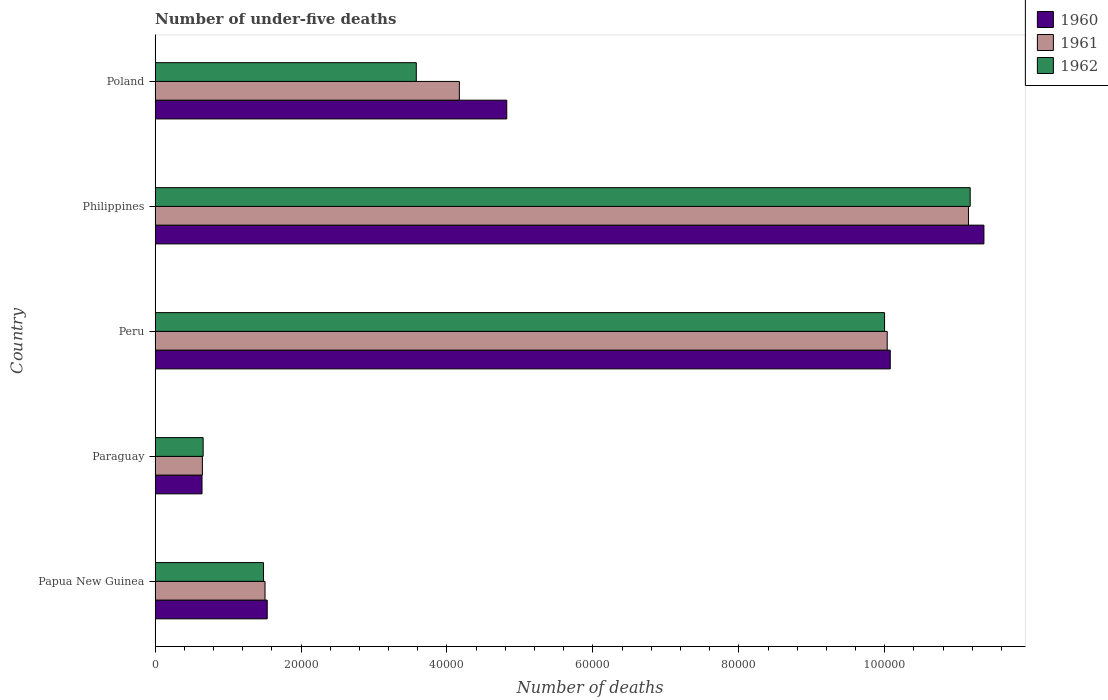How many different coloured bars are there?
Offer a very short reply. 3. How many groups of bars are there?
Your answer should be compact. 5. Are the number of bars per tick equal to the number of legend labels?
Keep it short and to the point. Yes. Are the number of bars on each tick of the Y-axis equal?
Provide a short and direct response. Yes. How many bars are there on the 5th tick from the bottom?
Make the answer very short. 3. What is the label of the 1st group of bars from the top?
Your answer should be compact. Poland. In how many cases, is the number of bars for a given country not equal to the number of legend labels?
Your answer should be very brief. 0. What is the number of under-five deaths in 1961 in Philippines?
Offer a terse response. 1.11e+05. Across all countries, what is the maximum number of under-five deaths in 1960?
Offer a very short reply. 1.14e+05. Across all countries, what is the minimum number of under-five deaths in 1960?
Your response must be concise. 6434. In which country was the number of under-five deaths in 1960 maximum?
Offer a terse response. Philippines. In which country was the number of under-five deaths in 1960 minimum?
Provide a succinct answer. Paraguay. What is the total number of under-five deaths in 1962 in the graph?
Ensure brevity in your answer.  2.69e+05. What is the difference between the number of under-five deaths in 1961 in Paraguay and that in Peru?
Make the answer very short. -9.38e+04. What is the difference between the number of under-five deaths in 1960 in Peru and the number of under-five deaths in 1962 in Poland?
Keep it short and to the point. 6.50e+04. What is the average number of under-five deaths in 1962 per country?
Offer a very short reply. 5.38e+04. What is the difference between the number of under-five deaths in 1961 and number of under-five deaths in 1962 in Peru?
Offer a very short reply. 362. What is the ratio of the number of under-five deaths in 1961 in Paraguay to that in Peru?
Provide a succinct answer. 0.06. Is the difference between the number of under-five deaths in 1961 in Paraguay and Philippines greater than the difference between the number of under-five deaths in 1962 in Paraguay and Philippines?
Offer a terse response. Yes. What is the difference between the highest and the second highest number of under-five deaths in 1962?
Your response must be concise. 1.17e+04. What is the difference between the highest and the lowest number of under-five deaths in 1961?
Make the answer very short. 1.05e+05. In how many countries, is the number of under-five deaths in 1961 greater than the average number of under-five deaths in 1961 taken over all countries?
Offer a very short reply. 2. What does the 2nd bar from the top in Philippines represents?
Your answer should be compact. 1961. How many countries are there in the graph?
Offer a very short reply. 5. What is the difference between two consecutive major ticks on the X-axis?
Keep it short and to the point. 2.00e+04. How many legend labels are there?
Provide a succinct answer. 3. How are the legend labels stacked?
Offer a terse response. Vertical. What is the title of the graph?
Provide a succinct answer. Number of under-five deaths. What is the label or title of the X-axis?
Make the answer very short. Number of deaths. What is the Number of deaths of 1960 in Papua New Guinea?
Offer a very short reply. 1.54e+04. What is the Number of deaths in 1961 in Papua New Guinea?
Provide a short and direct response. 1.51e+04. What is the Number of deaths in 1962 in Papua New Guinea?
Provide a succinct answer. 1.49e+04. What is the Number of deaths in 1960 in Paraguay?
Provide a succinct answer. 6434. What is the Number of deaths in 1961 in Paraguay?
Offer a terse response. 6486. What is the Number of deaths of 1962 in Paraguay?
Your answer should be very brief. 6590. What is the Number of deaths of 1960 in Peru?
Offer a terse response. 1.01e+05. What is the Number of deaths in 1961 in Peru?
Your answer should be very brief. 1.00e+05. What is the Number of deaths of 1962 in Peru?
Your answer should be very brief. 1.00e+05. What is the Number of deaths of 1960 in Philippines?
Your response must be concise. 1.14e+05. What is the Number of deaths in 1961 in Philippines?
Provide a short and direct response. 1.11e+05. What is the Number of deaths of 1962 in Philippines?
Ensure brevity in your answer.  1.12e+05. What is the Number of deaths of 1960 in Poland?
Your answer should be compact. 4.82e+04. What is the Number of deaths in 1961 in Poland?
Provide a short and direct response. 4.17e+04. What is the Number of deaths of 1962 in Poland?
Provide a succinct answer. 3.58e+04. Across all countries, what is the maximum Number of deaths in 1960?
Ensure brevity in your answer.  1.14e+05. Across all countries, what is the maximum Number of deaths in 1961?
Offer a terse response. 1.11e+05. Across all countries, what is the maximum Number of deaths of 1962?
Give a very brief answer. 1.12e+05. Across all countries, what is the minimum Number of deaths of 1960?
Your answer should be very brief. 6434. Across all countries, what is the minimum Number of deaths in 1961?
Your answer should be compact. 6486. Across all countries, what is the minimum Number of deaths of 1962?
Make the answer very short. 6590. What is the total Number of deaths in 1960 in the graph?
Offer a terse response. 2.84e+05. What is the total Number of deaths of 1961 in the graph?
Give a very brief answer. 2.75e+05. What is the total Number of deaths in 1962 in the graph?
Your answer should be compact. 2.69e+05. What is the difference between the Number of deaths in 1960 in Papua New Guinea and that in Paraguay?
Give a very brief answer. 8936. What is the difference between the Number of deaths in 1961 in Papua New Guinea and that in Paraguay?
Make the answer very short. 8582. What is the difference between the Number of deaths of 1962 in Papua New Guinea and that in Paraguay?
Keep it short and to the point. 8276. What is the difference between the Number of deaths in 1960 in Papua New Guinea and that in Peru?
Offer a terse response. -8.54e+04. What is the difference between the Number of deaths in 1961 in Papua New Guinea and that in Peru?
Your response must be concise. -8.53e+04. What is the difference between the Number of deaths of 1962 in Papua New Guinea and that in Peru?
Your answer should be very brief. -8.51e+04. What is the difference between the Number of deaths in 1960 in Papua New Guinea and that in Philippines?
Offer a very short reply. -9.82e+04. What is the difference between the Number of deaths of 1961 in Papua New Guinea and that in Philippines?
Provide a short and direct response. -9.64e+04. What is the difference between the Number of deaths of 1962 in Papua New Guinea and that in Philippines?
Your answer should be compact. -9.68e+04. What is the difference between the Number of deaths in 1960 in Papua New Guinea and that in Poland?
Give a very brief answer. -3.28e+04. What is the difference between the Number of deaths in 1961 in Papua New Guinea and that in Poland?
Make the answer very short. -2.66e+04. What is the difference between the Number of deaths of 1962 in Papua New Guinea and that in Poland?
Offer a terse response. -2.09e+04. What is the difference between the Number of deaths in 1960 in Paraguay and that in Peru?
Make the answer very short. -9.43e+04. What is the difference between the Number of deaths in 1961 in Paraguay and that in Peru?
Your response must be concise. -9.38e+04. What is the difference between the Number of deaths in 1962 in Paraguay and that in Peru?
Provide a short and direct response. -9.34e+04. What is the difference between the Number of deaths of 1960 in Paraguay and that in Philippines?
Your answer should be very brief. -1.07e+05. What is the difference between the Number of deaths in 1961 in Paraguay and that in Philippines?
Give a very brief answer. -1.05e+05. What is the difference between the Number of deaths of 1962 in Paraguay and that in Philippines?
Offer a very short reply. -1.05e+05. What is the difference between the Number of deaths in 1960 in Paraguay and that in Poland?
Your answer should be very brief. -4.18e+04. What is the difference between the Number of deaths in 1961 in Paraguay and that in Poland?
Give a very brief answer. -3.52e+04. What is the difference between the Number of deaths of 1962 in Paraguay and that in Poland?
Your response must be concise. -2.92e+04. What is the difference between the Number of deaths of 1960 in Peru and that in Philippines?
Your answer should be very brief. -1.28e+04. What is the difference between the Number of deaths of 1961 in Peru and that in Philippines?
Your response must be concise. -1.11e+04. What is the difference between the Number of deaths in 1962 in Peru and that in Philippines?
Ensure brevity in your answer.  -1.17e+04. What is the difference between the Number of deaths in 1960 in Peru and that in Poland?
Make the answer very short. 5.26e+04. What is the difference between the Number of deaths in 1961 in Peru and that in Poland?
Ensure brevity in your answer.  5.86e+04. What is the difference between the Number of deaths in 1962 in Peru and that in Poland?
Your answer should be compact. 6.42e+04. What is the difference between the Number of deaths in 1960 in Philippines and that in Poland?
Provide a short and direct response. 6.54e+04. What is the difference between the Number of deaths of 1961 in Philippines and that in Poland?
Offer a very short reply. 6.98e+04. What is the difference between the Number of deaths of 1962 in Philippines and that in Poland?
Provide a succinct answer. 7.59e+04. What is the difference between the Number of deaths in 1960 in Papua New Guinea and the Number of deaths in 1961 in Paraguay?
Your response must be concise. 8884. What is the difference between the Number of deaths of 1960 in Papua New Guinea and the Number of deaths of 1962 in Paraguay?
Provide a succinct answer. 8780. What is the difference between the Number of deaths in 1961 in Papua New Guinea and the Number of deaths in 1962 in Paraguay?
Ensure brevity in your answer.  8478. What is the difference between the Number of deaths in 1960 in Papua New Guinea and the Number of deaths in 1961 in Peru?
Offer a terse response. -8.50e+04. What is the difference between the Number of deaths in 1960 in Papua New Guinea and the Number of deaths in 1962 in Peru?
Offer a terse response. -8.46e+04. What is the difference between the Number of deaths in 1961 in Papua New Guinea and the Number of deaths in 1962 in Peru?
Make the answer very short. -8.49e+04. What is the difference between the Number of deaths of 1960 in Papua New Guinea and the Number of deaths of 1961 in Philippines?
Offer a terse response. -9.61e+04. What is the difference between the Number of deaths of 1960 in Papua New Guinea and the Number of deaths of 1962 in Philippines?
Offer a terse response. -9.63e+04. What is the difference between the Number of deaths in 1961 in Papua New Guinea and the Number of deaths in 1962 in Philippines?
Offer a terse response. -9.66e+04. What is the difference between the Number of deaths of 1960 in Papua New Guinea and the Number of deaths of 1961 in Poland?
Ensure brevity in your answer.  -2.63e+04. What is the difference between the Number of deaths in 1960 in Papua New Guinea and the Number of deaths in 1962 in Poland?
Provide a succinct answer. -2.04e+04. What is the difference between the Number of deaths of 1961 in Papua New Guinea and the Number of deaths of 1962 in Poland?
Offer a very short reply. -2.07e+04. What is the difference between the Number of deaths of 1960 in Paraguay and the Number of deaths of 1961 in Peru?
Provide a succinct answer. -9.39e+04. What is the difference between the Number of deaths in 1960 in Paraguay and the Number of deaths in 1962 in Peru?
Your answer should be compact. -9.35e+04. What is the difference between the Number of deaths in 1961 in Paraguay and the Number of deaths in 1962 in Peru?
Offer a terse response. -9.35e+04. What is the difference between the Number of deaths in 1960 in Paraguay and the Number of deaths in 1961 in Philippines?
Your answer should be very brief. -1.05e+05. What is the difference between the Number of deaths of 1960 in Paraguay and the Number of deaths of 1962 in Philippines?
Ensure brevity in your answer.  -1.05e+05. What is the difference between the Number of deaths of 1961 in Paraguay and the Number of deaths of 1962 in Philippines?
Your response must be concise. -1.05e+05. What is the difference between the Number of deaths of 1960 in Paraguay and the Number of deaths of 1961 in Poland?
Your response must be concise. -3.53e+04. What is the difference between the Number of deaths in 1960 in Paraguay and the Number of deaths in 1962 in Poland?
Offer a very short reply. -2.94e+04. What is the difference between the Number of deaths in 1961 in Paraguay and the Number of deaths in 1962 in Poland?
Your answer should be compact. -2.93e+04. What is the difference between the Number of deaths in 1960 in Peru and the Number of deaths in 1961 in Philippines?
Your answer should be very brief. -1.07e+04. What is the difference between the Number of deaths of 1960 in Peru and the Number of deaths of 1962 in Philippines?
Ensure brevity in your answer.  -1.10e+04. What is the difference between the Number of deaths of 1961 in Peru and the Number of deaths of 1962 in Philippines?
Provide a short and direct response. -1.14e+04. What is the difference between the Number of deaths of 1960 in Peru and the Number of deaths of 1961 in Poland?
Provide a succinct answer. 5.90e+04. What is the difference between the Number of deaths of 1960 in Peru and the Number of deaths of 1962 in Poland?
Make the answer very short. 6.50e+04. What is the difference between the Number of deaths in 1961 in Peru and the Number of deaths in 1962 in Poland?
Offer a terse response. 6.45e+04. What is the difference between the Number of deaths in 1960 in Philippines and the Number of deaths in 1961 in Poland?
Your answer should be very brief. 7.19e+04. What is the difference between the Number of deaths of 1960 in Philippines and the Number of deaths of 1962 in Poland?
Offer a terse response. 7.78e+04. What is the difference between the Number of deaths of 1961 in Philippines and the Number of deaths of 1962 in Poland?
Provide a short and direct response. 7.57e+04. What is the average Number of deaths of 1960 per country?
Ensure brevity in your answer.  5.69e+04. What is the average Number of deaths of 1961 per country?
Provide a succinct answer. 5.50e+04. What is the average Number of deaths in 1962 per country?
Provide a succinct answer. 5.38e+04. What is the difference between the Number of deaths in 1960 and Number of deaths in 1961 in Papua New Guinea?
Provide a succinct answer. 302. What is the difference between the Number of deaths in 1960 and Number of deaths in 1962 in Papua New Guinea?
Your response must be concise. 504. What is the difference between the Number of deaths in 1961 and Number of deaths in 1962 in Papua New Guinea?
Make the answer very short. 202. What is the difference between the Number of deaths in 1960 and Number of deaths in 1961 in Paraguay?
Give a very brief answer. -52. What is the difference between the Number of deaths in 1960 and Number of deaths in 1962 in Paraguay?
Keep it short and to the point. -156. What is the difference between the Number of deaths in 1961 and Number of deaths in 1962 in Paraguay?
Keep it short and to the point. -104. What is the difference between the Number of deaths of 1960 and Number of deaths of 1961 in Peru?
Your response must be concise. 416. What is the difference between the Number of deaths in 1960 and Number of deaths in 1962 in Peru?
Your answer should be compact. 778. What is the difference between the Number of deaths of 1961 and Number of deaths of 1962 in Peru?
Make the answer very short. 362. What is the difference between the Number of deaths in 1960 and Number of deaths in 1961 in Philippines?
Give a very brief answer. 2118. What is the difference between the Number of deaths in 1960 and Number of deaths in 1962 in Philippines?
Your response must be concise. 1883. What is the difference between the Number of deaths in 1961 and Number of deaths in 1962 in Philippines?
Your answer should be compact. -235. What is the difference between the Number of deaths of 1960 and Number of deaths of 1961 in Poland?
Ensure brevity in your answer.  6494. What is the difference between the Number of deaths of 1960 and Number of deaths of 1962 in Poland?
Your response must be concise. 1.24e+04. What is the difference between the Number of deaths of 1961 and Number of deaths of 1962 in Poland?
Your answer should be compact. 5902. What is the ratio of the Number of deaths of 1960 in Papua New Guinea to that in Paraguay?
Offer a very short reply. 2.39. What is the ratio of the Number of deaths in 1961 in Papua New Guinea to that in Paraguay?
Offer a very short reply. 2.32. What is the ratio of the Number of deaths in 1962 in Papua New Guinea to that in Paraguay?
Your response must be concise. 2.26. What is the ratio of the Number of deaths of 1960 in Papua New Guinea to that in Peru?
Offer a terse response. 0.15. What is the ratio of the Number of deaths in 1961 in Papua New Guinea to that in Peru?
Provide a succinct answer. 0.15. What is the ratio of the Number of deaths in 1962 in Papua New Guinea to that in Peru?
Your response must be concise. 0.15. What is the ratio of the Number of deaths in 1960 in Papua New Guinea to that in Philippines?
Make the answer very short. 0.14. What is the ratio of the Number of deaths of 1961 in Papua New Guinea to that in Philippines?
Your answer should be compact. 0.14. What is the ratio of the Number of deaths of 1962 in Papua New Guinea to that in Philippines?
Your response must be concise. 0.13. What is the ratio of the Number of deaths of 1960 in Papua New Guinea to that in Poland?
Make the answer very short. 0.32. What is the ratio of the Number of deaths in 1961 in Papua New Guinea to that in Poland?
Offer a very short reply. 0.36. What is the ratio of the Number of deaths of 1962 in Papua New Guinea to that in Poland?
Provide a short and direct response. 0.42. What is the ratio of the Number of deaths of 1960 in Paraguay to that in Peru?
Offer a terse response. 0.06. What is the ratio of the Number of deaths in 1961 in Paraguay to that in Peru?
Offer a very short reply. 0.06. What is the ratio of the Number of deaths in 1962 in Paraguay to that in Peru?
Offer a very short reply. 0.07. What is the ratio of the Number of deaths of 1960 in Paraguay to that in Philippines?
Offer a terse response. 0.06. What is the ratio of the Number of deaths of 1961 in Paraguay to that in Philippines?
Your response must be concise. 0.06. What is the ratio of the Number of deaths of 1962 in Paraguay to that in Philippines?
Provide a succinct answer. 0.06. What is the ratio of the Number of deaths in 1960 in Paraguay to that in Poland?
Offer a terse response. 0.13. What is the ratio of the Number of deaths in 1961 in Paraguay to that in Poland?
Give a very brief answer. 0.16. What is the ratio of the Number of deaths of 1962 in Paraguay to that in Poland?
Offer a terse response. 0.18. What is the ratio of the Number of deaths of 1960 in Peru to that in Philippines?
Give a very brief answer. 0.89. What is the ratio of the Number of deaths of 1961 in Peru to that in Philippines?
Keep it short and to the point. 0.9. What is the ratio of the Number of deaths of 1962 in Peru to that in Philippines?
Provide a short and direct response. 0.9. What is the ratio of the Number of deaths of 1960 in Peru to that in Poland?
Ensure brevity in your answer.  2.09. What is the ratio of the Number of deaths of 1961 in Peru to that in Poland?
Your answer should be compact. 2.41. What is the ratio of the Number of deaths of 1962 in Peru to that in Poland?
Provide a short and direct response. 2.79. What is the ratio of the Number of deaths of 1960 in Philippines to that in Poland?
Keep it short and to the point. 2.36. What is the ratio of the Number of deaths in 1961 in Philippines to that in Poland?
Keep it short and to the point. 2.67. What is the ratio of the Number of deaths in 1962 in Philippines to that in Poland?
Your answer should be compact. 3.12. What is the difference between the highest and the second highest Number of deaths in 1960?
Provide a short and direct response. 1.28e+04. What is the difference between the highest and the second highest Number of deaths in 1961?
Give a very brief answer. 1.11e+04. What is the difference between the highest and the second highest Number of deaths in 1962?
Offer a terse response. 1.17e+04. What is the difference between the highest and the lowest Number of deaths of 1960?
Your answer should be very brief. 1.07e+05. What is the difference between the highest and the lowest Number of deaths of 1961?
Keep it short and to the point. 1.05e+05. What is the difference between the highest and the lowest Number of deaths of 1962?
Give a very brief answer. 1.05e+05. 